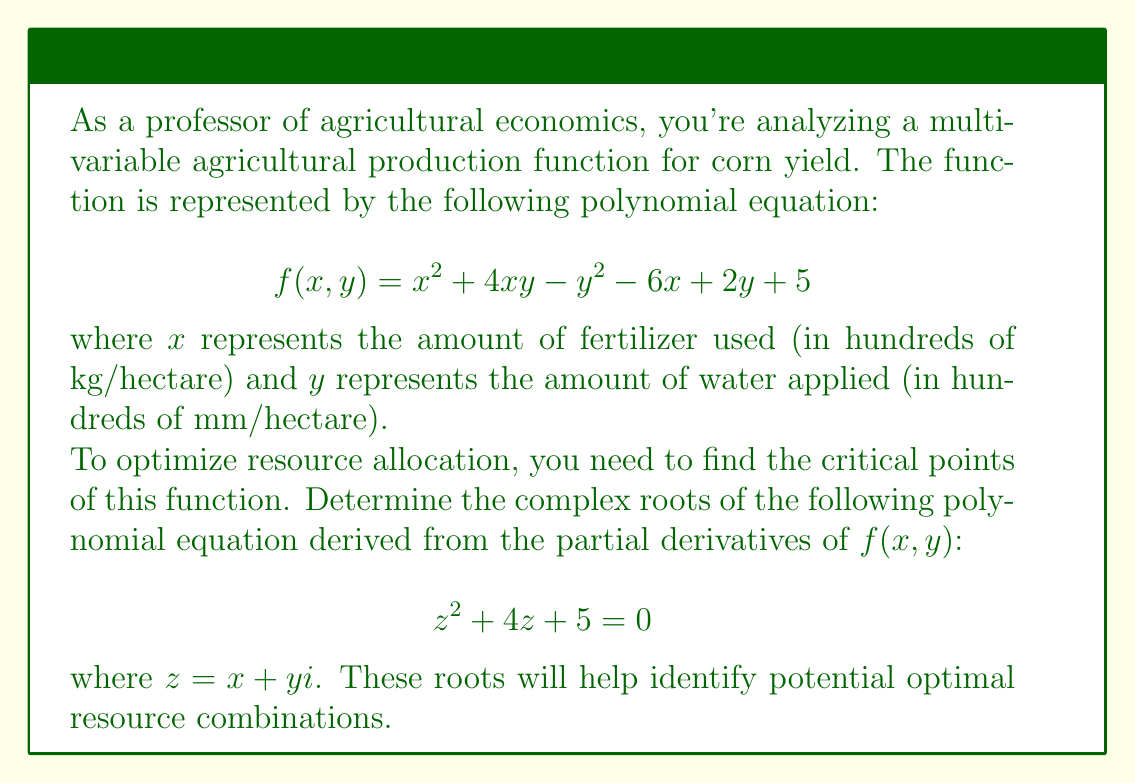Teach me how to tackle this problem. To solve this quadratic equation in the complex plane, we'll use the quadratic formula:

$$ z = \frac{-b \pm \sqrt{b^2 - 4ac}}{2a} $$

Where $a = 1$, $b = 4$, and $c = 5$.

1) First, calculate the discriminant:
   $$ b^2 - 4ac = 4^2 - 4(1)(5) = 16 - 20 = -4 $$

2) The negative discriminant indicates complex roots.

3) Substitute into the quadratic formula:
   $$ z = \frac{-4 \pm \sqrt{-4}}{2(1)} = -2 \pm \frac{\sqrt{4}}{2}i = -2 \pm i $$

4) Therefore, the two complex roots are:
   $$ z_1 = -2 + i $$
   $$ z_2 = -2 - i $$

These complex roots represent the solutions to the equation derived from the partial derivatives of the original production function. In the context of agricultural economics, these points could indicate potential optimal or critical resource combinations for fertilizer and water usage, although their practical interpretation would require further economic analysis.
Answer: The complex roots of the equation $z^2 + 4z + 5 = 0$ are:
$$ z_1 = -2 + i $$ and $$ z_2 = -2 - i $$ 